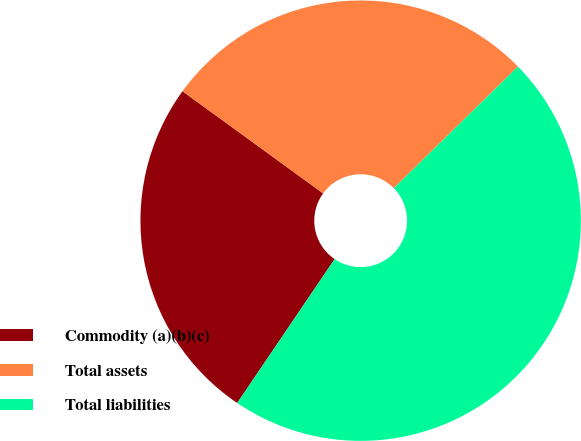Convert chart. <chart><loc_0><loc_0><loc_500><loc_500><pie_chart><fcel>Commodity (a)(b)(c)<fcel>Total assets<fcel>Total liabilities<nl><fcel>25.53%<fcel>27.66%<fcel>46.81%<nl></chart> 